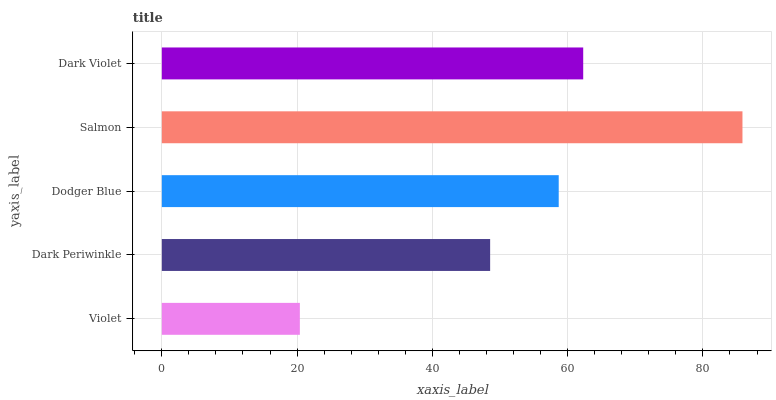Is Violet the minimum?
Answer yes or no. Yes. Is Salmon the maximum?
Answer yes or no. Yes. Is Dark Periwinkle the minimum?
Answer yes or no. No. Is Dark Periwinkle the maximum?
Answer yes or no. No. Is Dark Periwinkle greater than Violet?
Answer yes or no. Yes. Is Violet less than Dark Periwinkle?
Answer yes or no. Yes. Is Violet greater than Dark Periwinkle?
Answer yes or no. No. Is Dark Periwinkle less than Violet?
Answer yes or no. No. Is Dodger Blue the high median?
Answer yes or no. Yes. Is Dodger Blue the low median?
Answer yes or no. Yes. Is Salmon the high median?
Answer yes or no. No. Is Salmon the low median?
Answer yes or no. No. 